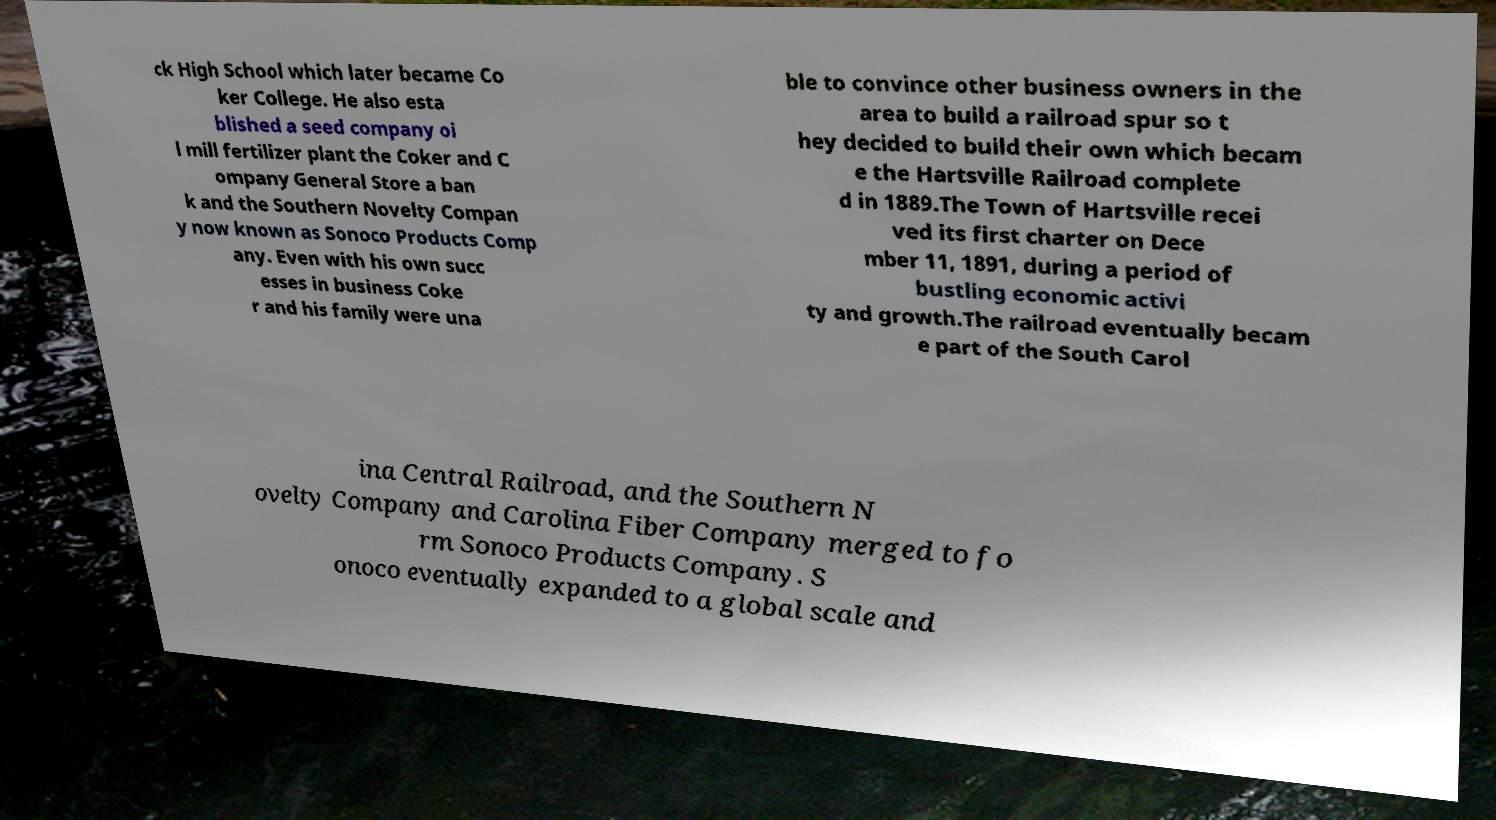Please read and relay the text visible in this image. What does it say? ck High School which later became Co ker College. He also esta blished a seed company oi l mill fertilizer plant the Coker and C ompany General Store a ban k and the Southern Novelty Compan y now known as Sonoco Products Comp any. Even with his own succ esses in business Coke r and his family were una ble to convince other business owners in the area to build a railroad spur so t hey decided to build their own which becam e the Hartsville Railroad complete d in 1889.The Town of Hartsville recei ved its first charter on Dece mber 11, 1891, during a period of bustling economic activi ty and growth.The railroad eventually becam e part of the South Carol ina Central Railroad, and the Southern N ovelty Company and Carolina Fiber Company merged to fo rm Sonoco Products Company. S onoco eventually expanded to a global scale and 